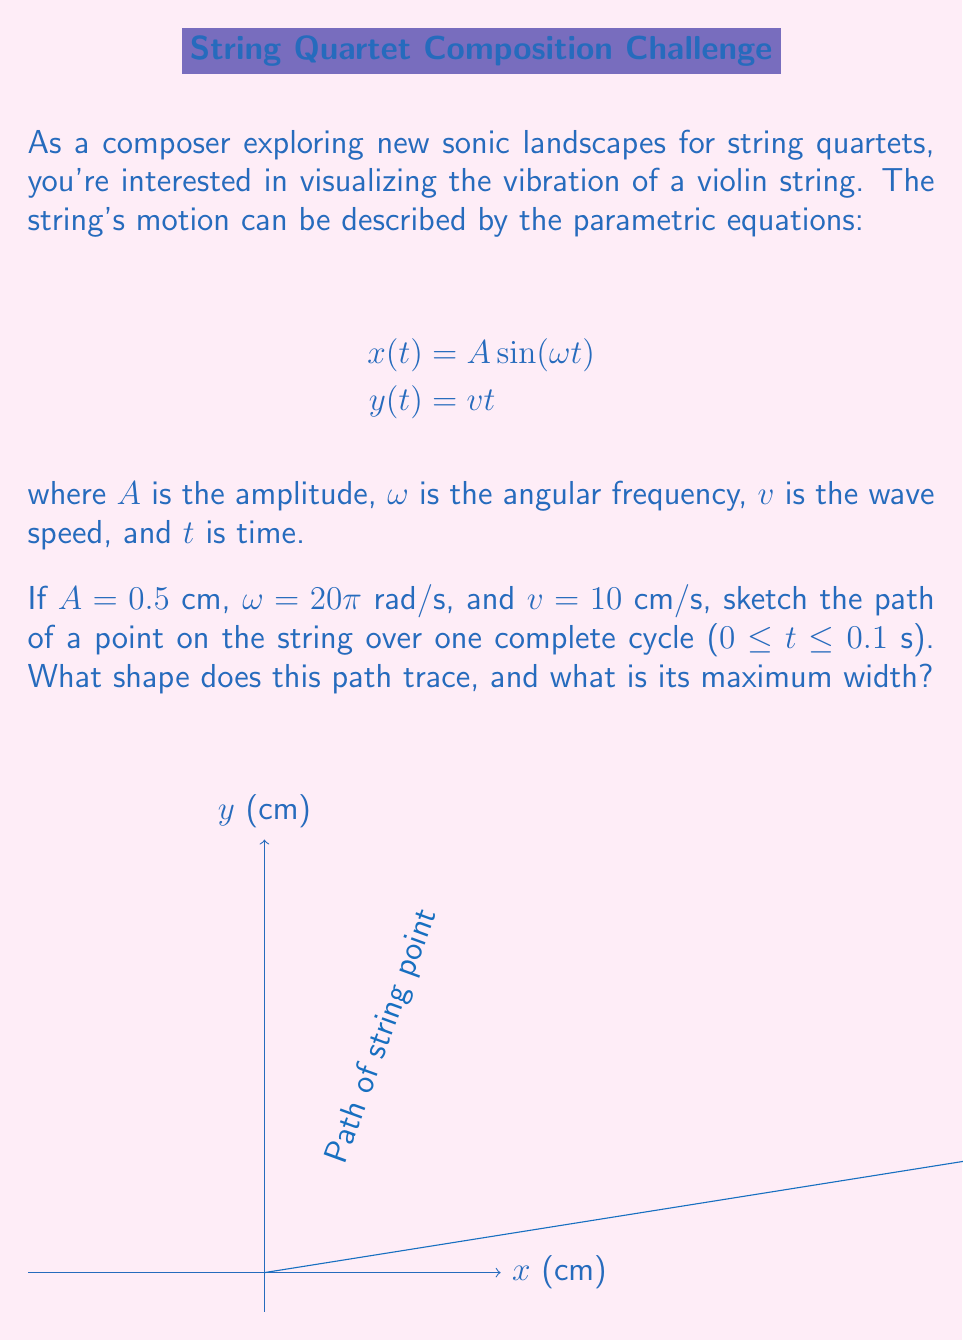Provide a solution to this math problem. Let's approach this step-by-step:

1) First, we need to understand what these equations represent:
   - $x(t) = A \sin(\omega t)$ describes the lateral displacement of the string
   - $y(t) = vt$ describes the longitudinal motion of the wave along the string

2) We're given:
   $A = 0.5$ cm
   $\omega = 20\pi$ rad/s
   $v = 10$ cm/s
   $0 \leq t \leq 0.1$ s

3) Let's consider the x-direction motion:
   - The sine function oscillates between -1 and 1
   - So $x(t)$ will oscillate between $-A$ and $A$
   - The maximum width of the path is therefore $2A = 2(0.5) = 1$ cm

4) In the y-direction:
   - At $t = 0$, $y = 0$
   - At $t = 0.1$, $y = vt = 10(0.1) = 1$ cm

5) The path traced will be a sine wave "stretched out" over time. This is because:
   - The x-coordinate oscillates sinusoidally
   - The y-coordinate increases linearly with time

6) This type of path is known as a sine curve or sinusoid

7) To visualize this, imagine a point moving up at a constant speed while simultaneously oscillating left and right

The resulting shape, as shown in the diagram, is a sine curve with a width of 1 cm and a length of 1 cm over one complete cycle.
Answer: Sinusoid with maximum width 1 cm 